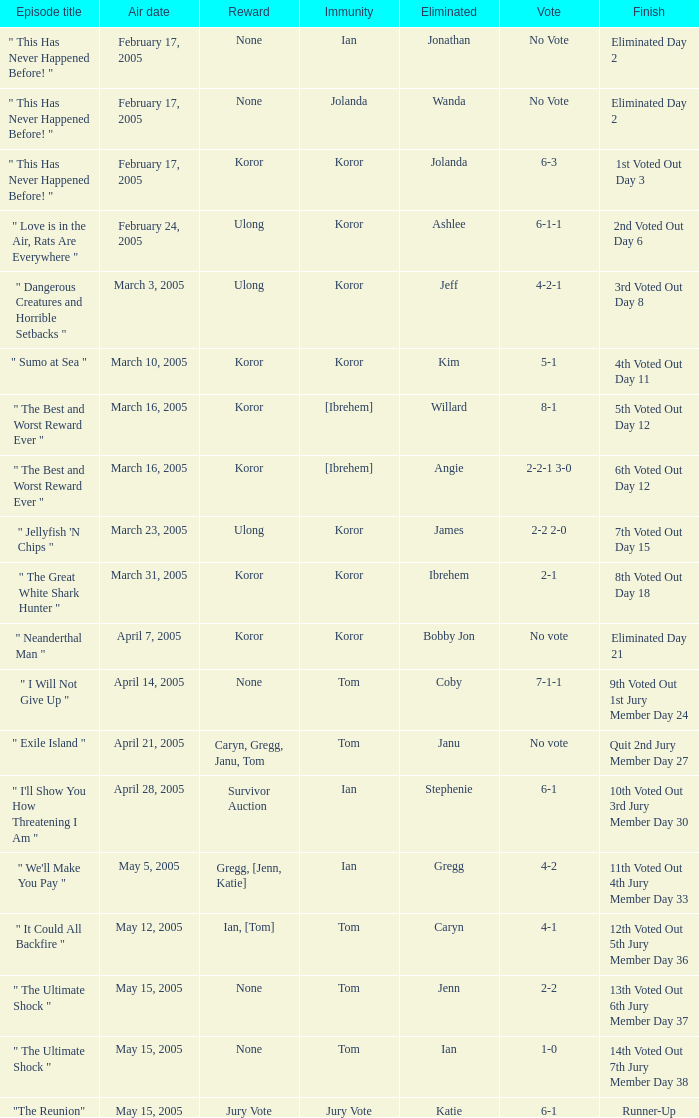How many persons had immunity in the episode when Wanda was eliminated? 1.0. 